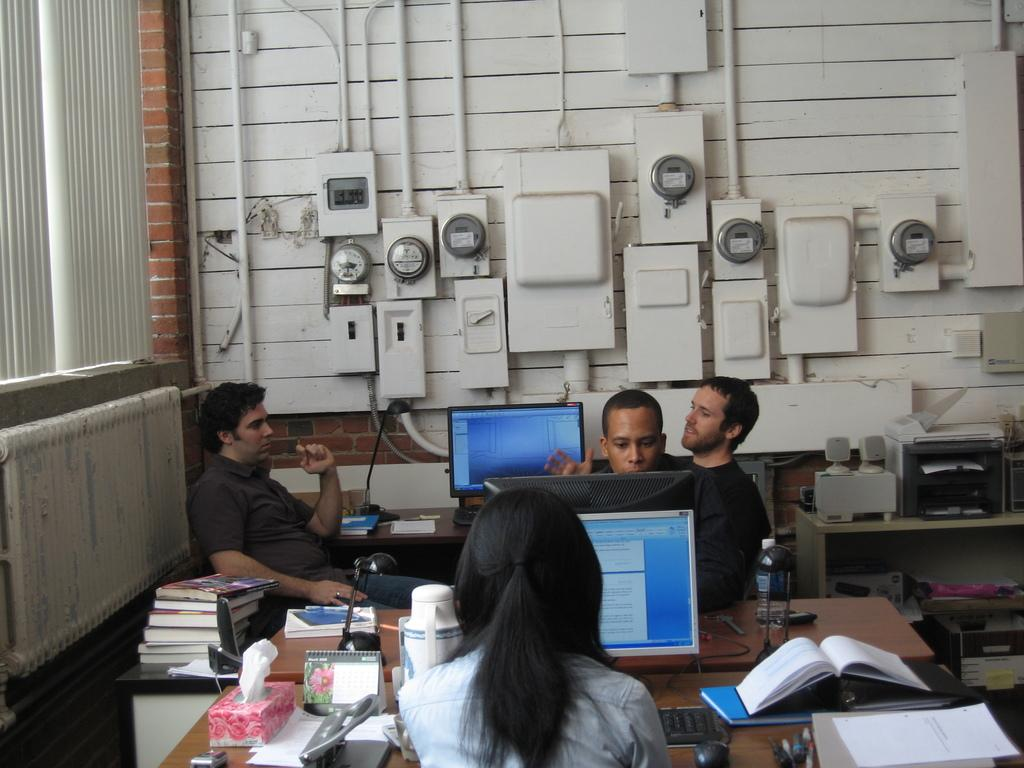How many people are in the image? There is a group of people in the image, but the exact number cannot be determined from the provided facts. What are the people doing in the image? The people are sitting in front of a table. What can be seen on the table in the image? There is a monitor and books on the table, along with other objects. What type of linen is draped over the monitor in the image? There is no linen draped over the monitor in the image; only the monitor and books are mentioned as being on the table. 